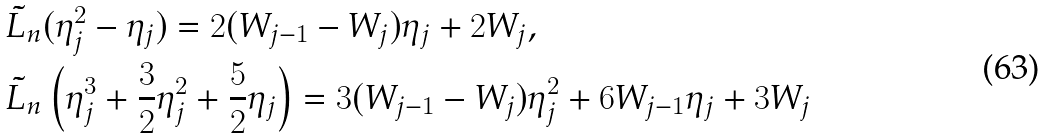Convert formula to latex. <formula><loc_0><loc_0><loc_500><loc_500>& \tilde { L } _ { n } ( \eta _ { j } ^ { 2 } - \eta _ { j } ) = 2 ( W _ { j - 1 } - W _ { j } ) \eta _ { j } + 2 W _ { j } , \\ & \tilde { L } _ { n } \left ( \eta _ { j } ^ { 3 } + \frac { 3 } { 2 } \eta _ { j } ^ { 2 } + \frac { 5 } { 2 } \eta _ { j } \right ) = 3 ( W _ { j - 1 } - W _ { j } ) \eta _ { j } ^ { 2 } + 6 W _ { j - 1 } \eta _ { j } + 3 W _ { j }</formula> 